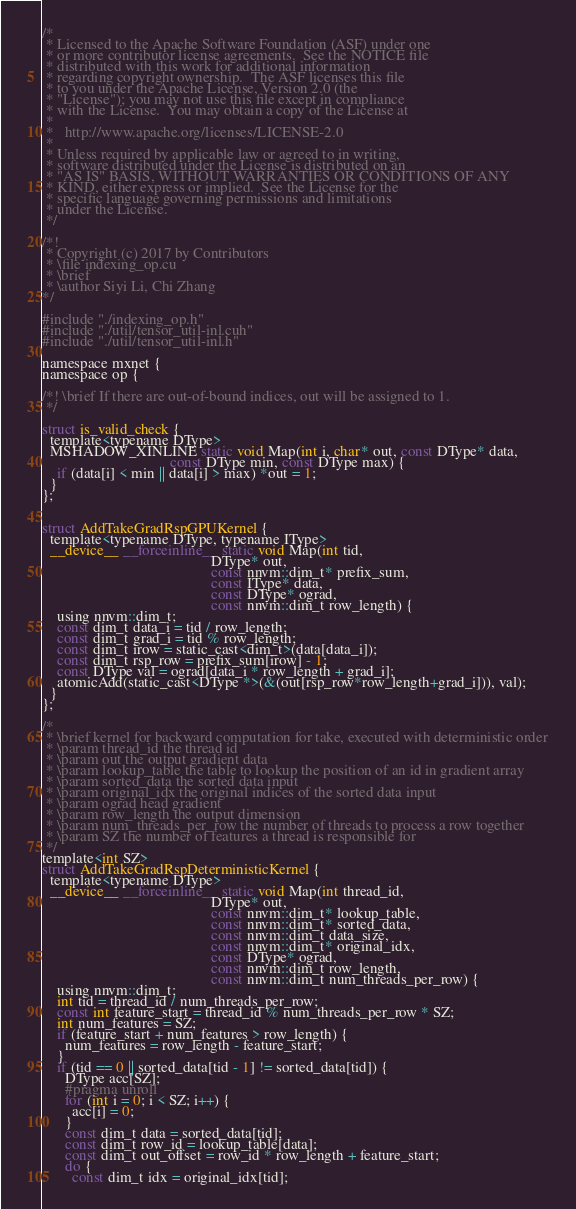Convert code to text. <code><loc_0><loc_0><loc_500><loc_500><_Cuda_>/*
 * Licensed to the Apache Software Foundation (ASF) under one
 * or more contributor license agreements.  See the NOTICE file
 * distributed with this work for additional information
 * regarding copyright ownership.  The ASF licenses this file
 * to you under the Apache License, Version 2.0 (the
 * "License"); you may not use this file except in compliance
 * with the License.  You may obtain a copy of the License at
 *
 *   http://www.apache.org/licenses/LICENSE-2.0
 *
 * Unless required by applicable law or agreed to in writing,
 * software distributed under the License is distributed on an
 * "AS IS" BASIS, WITHOUT WARRANTIES OR CONDITIONS OF ANY
 * KIND, either express or implied.  See the License for the
 * specific language governing permissions and limitations
 * under the License.
 */

/*!
 * Copyright (c) 2017 by Contributors
 * \file indexing_op.cu
 * \brief
 * \author Siyi Li, Chi Zhang
*/

#include "./indexing_op.h"
#include "./util/tensor_util-inl.cuh"
#include "./util/tensor_util-inl.h"

namespace mxnet {
namespace op {

/*! \brief If there are out-of-bound indices, out will be assigned to 1.
 */

struct is_valid_check {
  template<typename DType>
  MSHADOW_XINLINE static void Map(int i, char* out, const DType* data,
                                  const DType min, const DType max) {
    if (data[i] < min || data[i] > max) *out = 1;
  }
};


struct AddTakeGradRspGPUKernel {
  template<typename DType, typename IType>
  __device__ __forceinline__ static void Map(int tid,
                                             DType* out,
                                             const nnvm::dim_t* prefix_sum,
                                             const IType* data,
                                             const DType* ograd,
                                             const nnvm::dim_t row_length) {
    using nnvm::dim_t;
    const dim_t data_i = tid / row_length;
    const dim_t grad_i = tid % row_length;
    const dim_t irow = static_cast<dim_t>(data[data_i]);
    const dim_t rsp_row = prefix_sum[irow] - 1;
    const DType val = ograd[data_i * row_length + grad_i];
    atomicAdd(static_cast<DType *>(&(out[rsp_row*row_length+grad_i])), val);
  }
};

/*
 * \brief kernel for backward computation for take, executed with deterministic order
 * \param thread_id the thread id
 * \param out the output gradient data
 * \param lookup_table the table to lookup the position of an id in gradient array
 * \param sorted_data the sorted data input
 * \param original_idx the original indices of the sorted data input
 * \param ograd head gradient
 * \param row_length the output dimension
 * \param num_threads_per_row the number of threads to process a row together
 * \param SZ the number of features a thread is responsible for
 */
template<int SZ>
struct AddTakeGradRspDeterministicKernel {
  template<typename DType>
  __device__ __forceinline__ static void Map(int thread_id,
                                             DType* out,
                                             const nnvm::dim_t* lookup_table,
                                             const nnvm::dim_t* sorted_data,
                                             const nnvm::dim_t data_size,
                                             const nnvm::dim_t* original_idx,
                                             const DType* ograd,
                                             const nnvm::dim_t row_length,
                                             const nnvm::dim_t num_threads_per_row) {
    using nnvm::dim_t;
    int tid = thread_id / num_threads_per_row;
    const int feature_start = thread_id % num_threads_per_row * SZ;
    int num_features = SZ;
    if (feature_start + num_features > row_length) {
      num_features = row_length - feature_start;
    }
    if (tid == 0 || sorted_data[tid - 1] != sorted_data[tid]) {
      DType acc[SZ];
      #pragma unroll
      for (int i = 0; i < SZ; i++) {
        acc[i] = 0;
      }
      const dim_t data = sorted_data[tid];
      const dim_t row_id = lookup_table[data];
      const dim_t out_offset = row_id * row_length + feature_start;
      do {
        const dim_t idx = original_idx[tid];</code> 